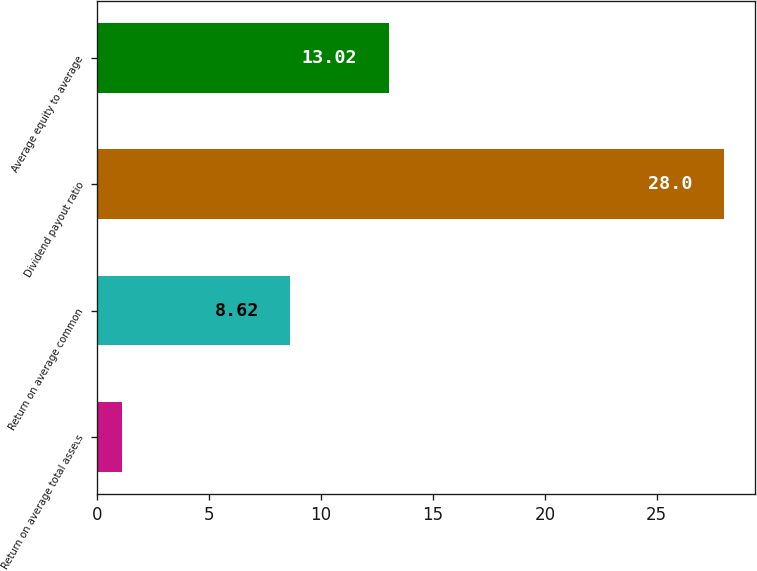Convert chart. <chart><loc_0><loc_0><loc_500><loc_500><bar_chart><fcel>Return on average total assets<fcel>Return on average common<fcel>Dividend payout ratio<fcel>Average equity to average<nl><fcel>1.11<fcel>8.62<fcel>28<fcel>13.02<nl></chart> 